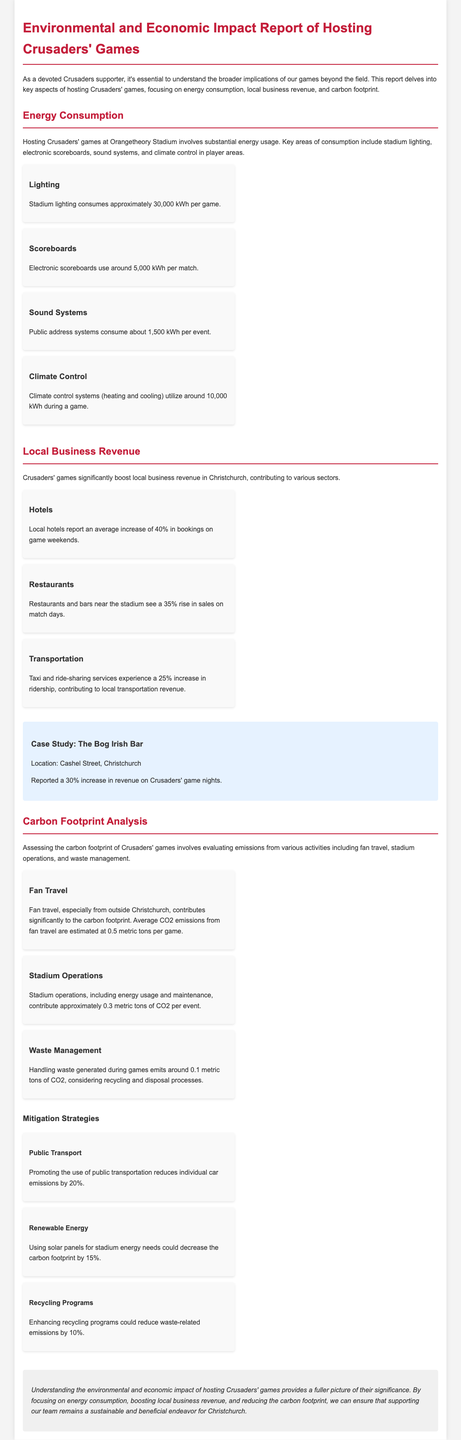what is the energy consumption of stadium lighting per game? The document states that stadium lighting consumes approximately 30,000 kWh per game.
Answer: 30,000 kWh what percentage increase do local hotels report on game weekends? According to the report, local hotels report an average increase of 40% in bookings on game weekends.
Answer: 40% how much CO2 emissions are estimated from fan travel per game? The average CO2 emissions from fan travel are estimated at 0.5 metric tons per game.
Answer: 0.5 metric tons what is the increase in revenue reported by The Bog Irish Bar on game nights? The case study indicates that The Bog Irish Bar reported a 30% increase in revenue on Crusaders' game nights.
Answer: 30% what is one mitigation strategy to reduce individual car emissions? The document suggests that promoting the use of public transportation reduces individual car emissions by 20%.
Answer: Public Transport how many kWh does climate control consume during a game? Climate control systems utilize around 10,000 kWh during a game.
Answer: 10,000 kWh what is the contribution of stadium operations to CO2 emissions per event? Stadium operations contribute approximately 0.3 metric tons of CO2 per event.
Answer: 0.3 metric tons what is the increase in restaurant sales reported on match days? Restaurants and bars near the stadium see a 35% rise in sales on match days.
Answer: 35% what is the total energy used by electronic scoreboards during a match? Electronic scoreboards use around 5,000 kWh per match.
Answer: 5,000 kWh 